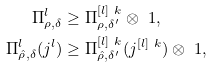Convert formula to latex. <formula><loc_0><loc_0><loc_500><loc_500>\Pi ^ { l } _ { \rho , \delta } & \geq \Pi ^ { [ l ] \ k } _ { \rho , \delta ^ { \prime } } \otimes \ 1 , \\ \Pi ^ { l } _ { \hat { \rho } , \delta } ( j ^ { l } ) & \geq \Pi ^ { [ l ] \ k } _ { \hat { \rho } , \delta ^ { \prime } } ( j ^ { [ l ] \ k } ) \otimes \ 1 ,</formula> 